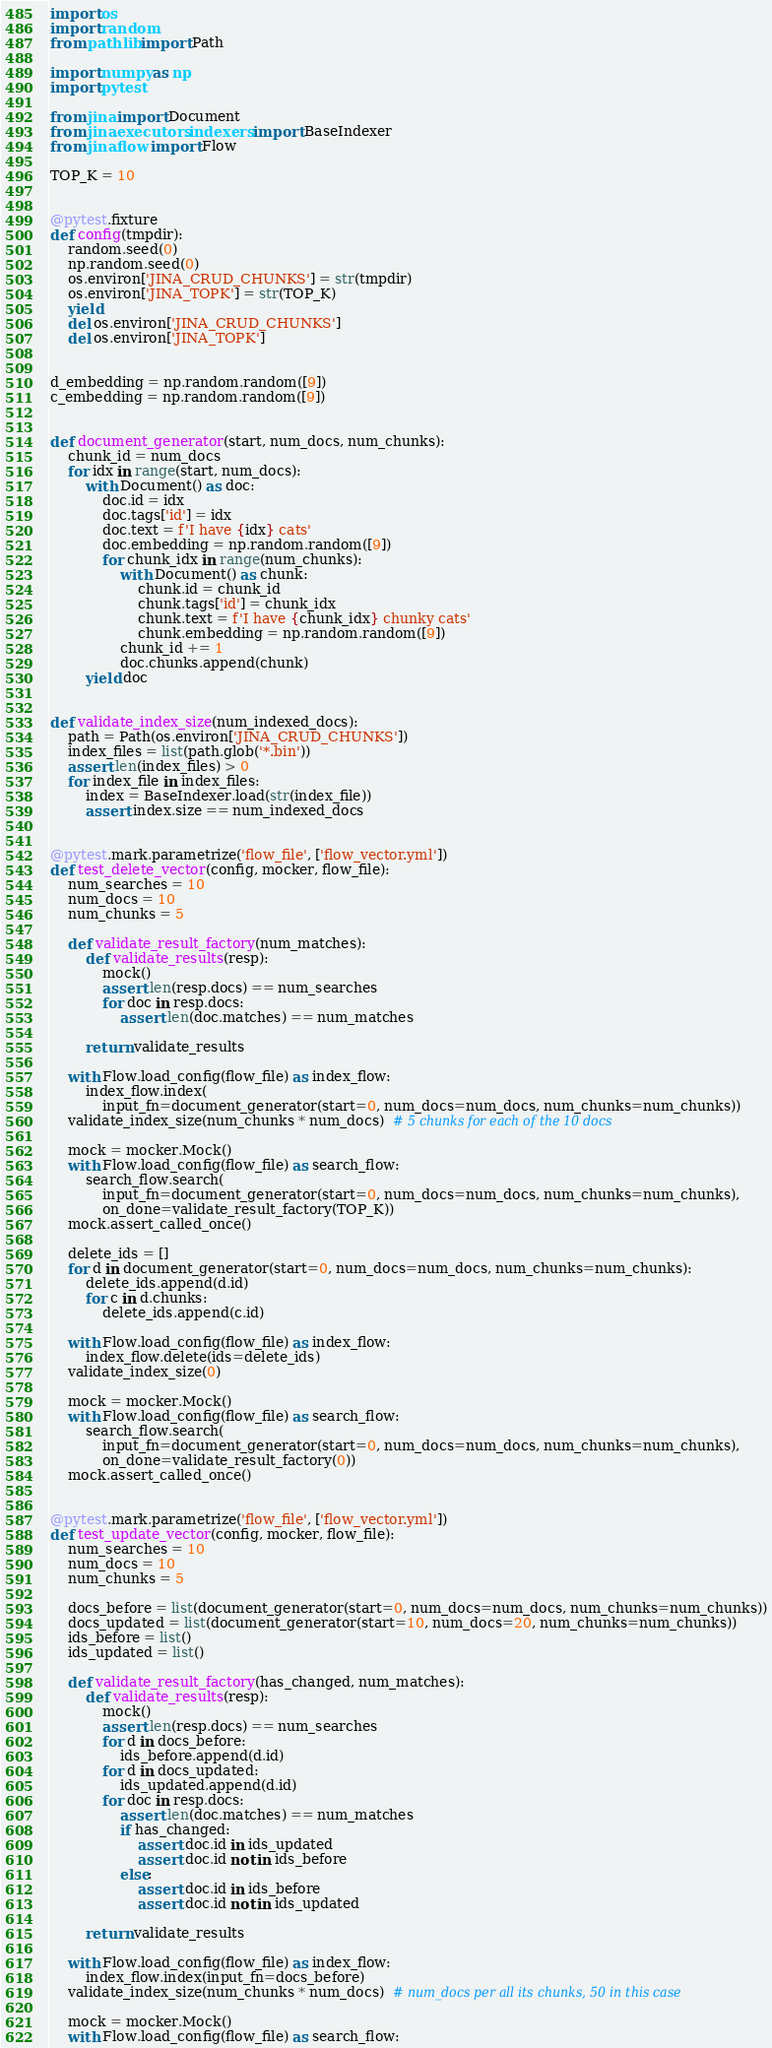<code> <loc_0><loc_0><loc_500><loc_500><_Python_>import os
import random
from pathlib import Path

import numpy as np
import pytest

from jina import Document
from jina.executors.indexers import BaseIndexer
from jina.flow import Flow

TOP_K = 10


@pytest.fixture
def config(tmpdir):
    random.seed(0)
    np.random.seed(0)
    os.environ['JINA_CRUD_CHUNKS'] = str(tmpdir)
    os.environ['JINA_TOPK'] = str(TOP_K)
    yield
    del os.environ['JINA_CRUD_CHUNKS']
    del os.environ['JINA_TOPK']


d_embedding = np.random.random([9])
c_embedding = np.random.random([9])


def document_generator(start, num_docs, num_chunks):
    chunk_id = num_docs
    for idx in range(start, num_docs):
        with Document() as doc:
            doc.id = idx
            doc.tags['id'] = idx
            doc.text = f'I have {idx} cats'
            doc.embedding = np.random.random([9])
            for chunk_idx in range(num_chunks):
                with Document() as chunk:
                    chunk.id = chunk_id
                    chunk.tags['id'] = chunk_idx
                    chunk.text = f'I have {chunk_idx} chunky cats'
                    chunk.embedding = np.random.random([9])
                chunk_id += 1
                doc.chunks.append(chunk)
        yield doc


def validate_index_size(num_indexed_docs):
    path = Path(os.environ['JINA_CRUD_CHUNKS'])
    index_files = list(path.glob('*.bin'))
    assert len(index_files) > 0
    for index_file in index_files:
        index = BaseIndexer.load(str(index_file))
        assert index.size == num_indexed_docs


@pytest.mark.parametrize('flow_file', ['flow_vector.yml'])
def test_delete_vector(config, mocker, flow_file):
    num_searches = 10
    num_docs = 10
    num_chunks = 5

    def validate_result_factory(num_matches):
        def validate_results(resp):
            mock()
            assert len(resp.docs) == num_searches
            for doc in resp.docs:
                assert len(doc.matches) == num_matches

        return validate_results

    with Flow.load_config(flow_file) as index_flow:
        index_flow.index(
            input_fn=document_generator(start=0, num_docs=num_docs, num_chunks=num_chunks))
    validate_index_size(num_chunks * num_docs)  # 5 chunks for each of the 10 docs

    mock = mocker.Mock()
    with Flow.load_config(flow_file) as search_flow:
        search_flow.search(
            input_fn=document_generator(start=0, num_docs=num_docs, num_chunks=num_chunks),
            on_done=validate_result_factory(TOP_K))
    mock.assert_called_once()

    delete_ids = []
    for d in document_generator(start=0, num_docs=num_docs, num_chunks=num_chunks):
        delete_ids.append(d.id)
        for c in d.chunks:
            delete_ids.append(c.id)

    with Flow.load_config(flow_file) as index_flow:
        index_flow.delete(ids=delete_ids)
    validate_index_size(0)

    mock = mocker.Mock()
    with Flow.load_config(flow_file) as search_flow:
        search_flow.search(
            input_fn=document_generator(start=0, num_docs=num_docs, num_chunks=num_chunks),
            on_done=validate_result_factory(0))
    mock.assert_called_once()


@pytest.mark.parametrize('flow_file', ['flow_vector.yml'])
def test_update_vector(config, mocker, flow_file):
    num_searches = 10
    num_docs = 10
    num_chunks = 5

    docs_before = list(document_generator(start=0, num_docs=num_docs, num_chunks=num_chunks))
    docs_updated = list(document_generator(start=10, num_docs=20, num_chunks=num_chunks))
    ids_before = list()
    ids_updated = list()

    def validate_result_factory(has_changed, num_matches):
        def validate_results(resp):
            mock()
            assert len(resp.docs) == num_searches
            for d in docs_before:
                ids_before.append(d.id)
            for d in docs_updated:
                ids_updated.append(d.id)
            for doc in resp.docs:
                assert len(doc.matches) == num_matches
                if has_changed:
                    assert doc.id in ids_updated
                    assert doc.id not in ids_before
                else:
                    assert doc.id in ids_before
                    assert doc.id not in ids_updated

        return validate_results

    with Flow.load_config(flow_file) as index_flow:
        index_flow.index(input_fn=docs_before)
    validate_index_size(num_chunks * num_docs)  # num_docs per all its chunks, 50 in this case

    mock = mocker.Mock()
    with Flow.load_config(flow_file) as search_flow:</code> 